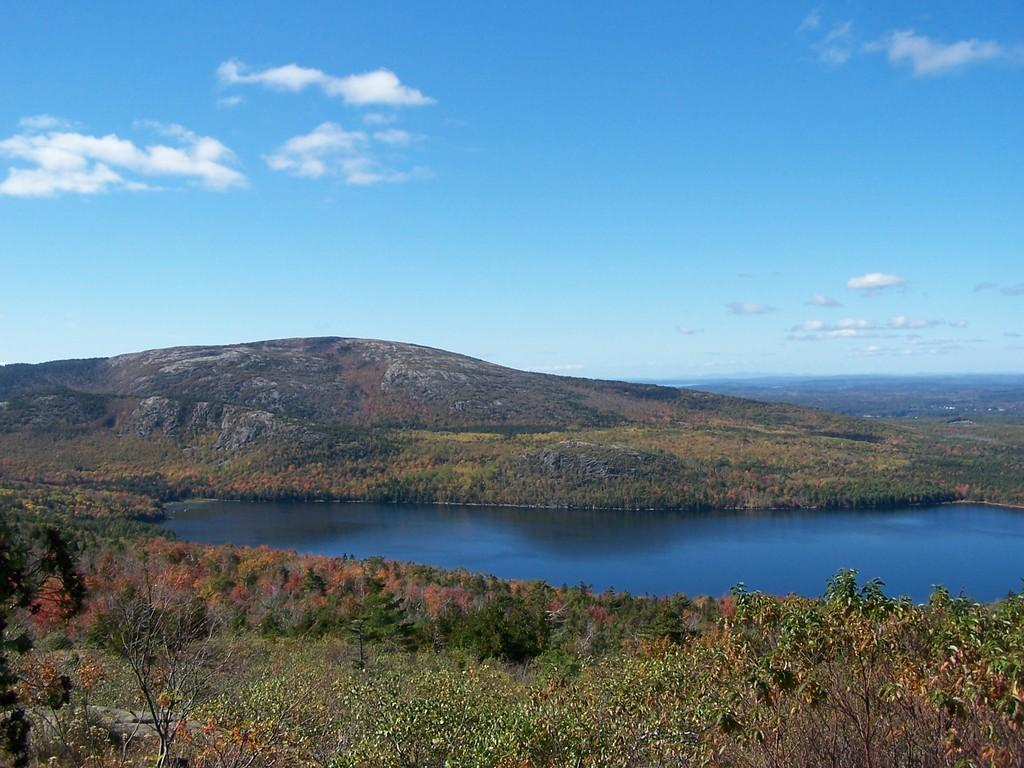What type of natural feature can be seen in the image? There is a river in the image. What other natural elements are present in the image? There are trees and a hill in the image. What is visible in the background of the image? The sky is visible in the image. What type of design can be seen on the ship in the image? There is no ship present in the image; it features a river, trees, a hill, and the sky. 